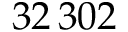<formula> <loc_0><loc_0><loc_500><loc_500>3 2 \, 3 0 2</formula> 